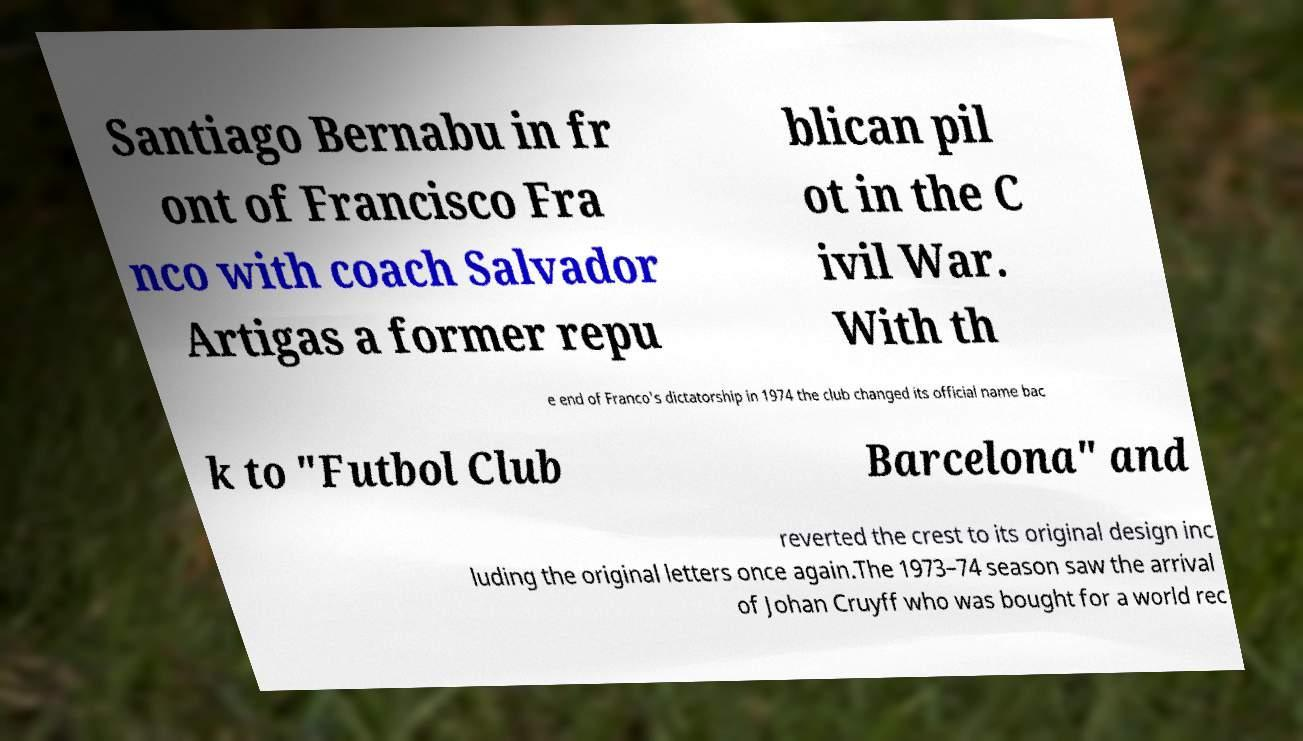I need the written content from this picture converted into text. Can you do that? Santiago Bernabu in fr ont of Francisco Fra nco with coach Salvador Artigas a former repu blican pil ot in the C ivil War. With th e end of Franco's dictatorship in 1974 the club changed its official name bac k to "Futbol Club Barcelona" and reverted the crest to its original design inc luding the original letters once again.The 1973–74 season saw the arrival of Johan Cruyff who was bought for a world rec 